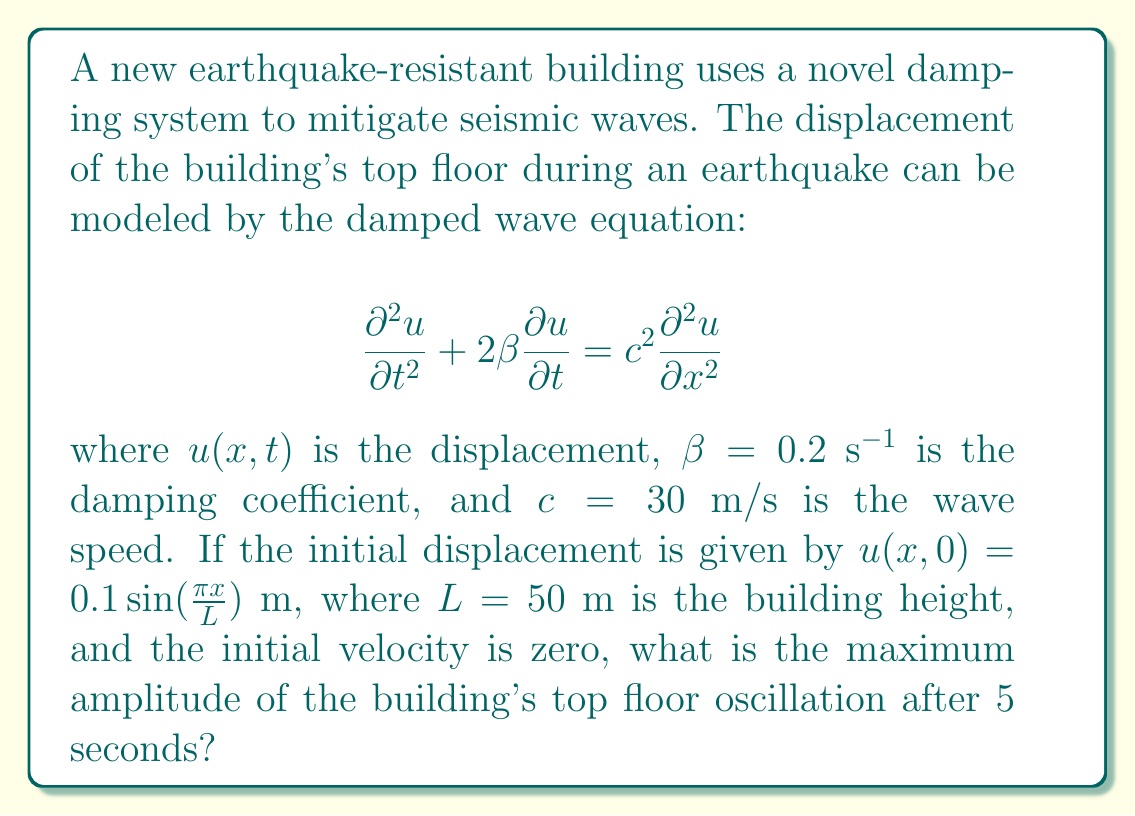What is the answer to this math problem? Let's approach this step-by-step:

1) The general solution for a damped wave equation with the given initial conditions is:

   $$u(x,t) = Ae^{-\beta t} \sin(\omega t) \sin(\frac{\pi x}{L})$$

   where $A$ is the initial amplitude, and $\omega$ is the angular frequency.

2) We're given that $A = 0.1$ m and $L = 50$ m.

3) To find $\omega$, we use the dispersion relation:

   $$\omega^2 = c^2(\frac{\pi}{L})^2 - \beta^2$$

4) Substituting the values:

   $$\omega^2 = 30^2(\frac{\pi}{50})^2 - 0.2^2 = 3.5488$$

   $$\omega = \sqrt{3.5488} = 1.8839 \text{ rad/s}$$

5) Now, our solution becomes:

   $$u(x,t) = 0.1e^{-0.2t} \sin(1.8839t) \sin(\frac{\pi x}{50})$$

6) The maximum amplitude occurs at the top of the building where $x = L = 50$ m, and $\sin(\frac{\pi x}{L}) = 1$. So, we're left with:

   $$u(50,t) = 0.1e^{-0.2t} \sin(1.8839t)$$

7) To find the maximum amplitude at t = 5 s, we calculate:

   $$u(50,5) = 0.1e^{-0.2(5)} \sin(1.8839(5)) = 0.0404 \sin(9.4195) = 0.0368 \text{ m}$$

8) Therefore, the maximum amplitude of oscillation after 5 seconds is approximately 0.0368 m or 3.68 cm.
Answer: 3.68 cm 